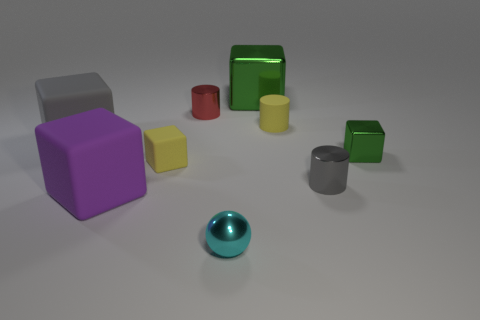Is there a pattern in how the objects are arranged? There doesn't appear to be a specific pattern to the arrangement of the objects. They are scattered randomly across the surface, which may point to them being mid-use or casually placed without a set order. 